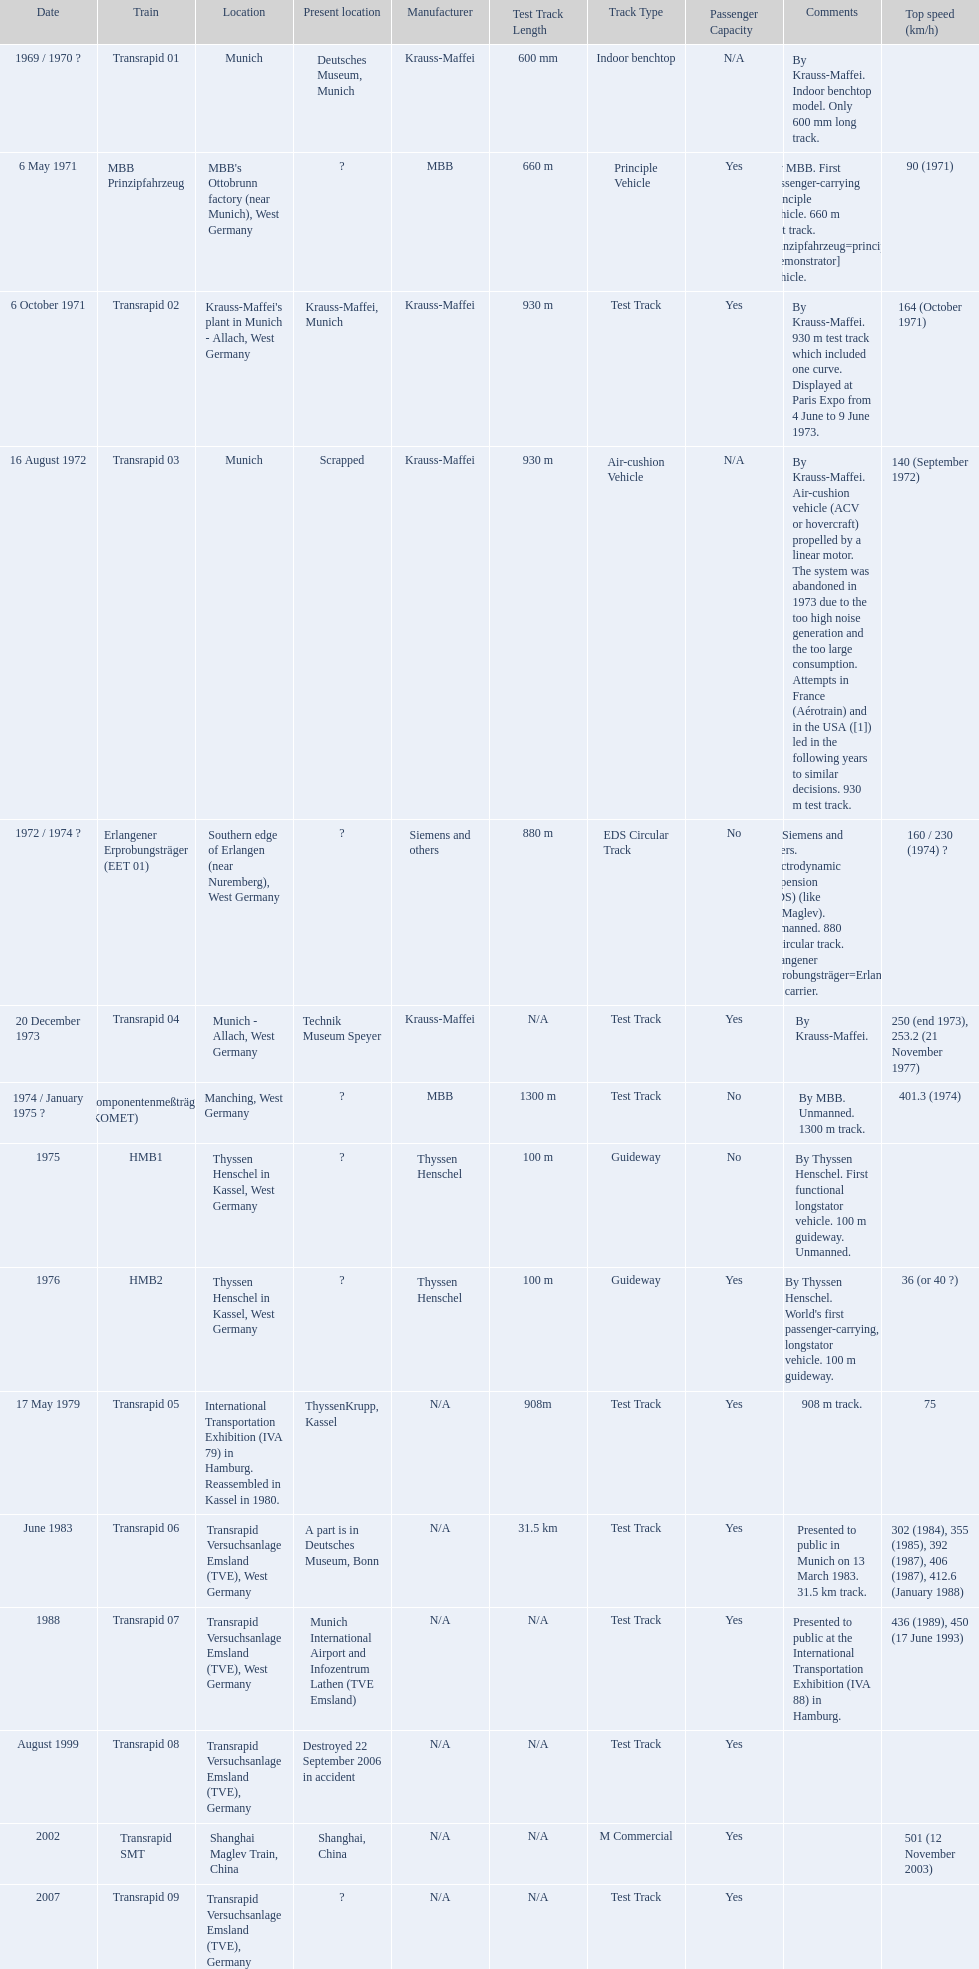How many versions have been scrapped? 1. Could you parse the entire table? {'header': ['Date', 'Train', 'Location', 'Present location', 'Manufacturer', 'Test Track Length', 'Track Type', 'Passenger Capacity', 'Comments', 'Top speed (km/h)'], 'rows': [['1969 / 1970\xa0?', 'Transrapid 01', 'Munich', 'Deutsches Museum, Munich', 'Krauss-Maffei', '600 mm', 'Indoor benchtop', 'N/A', 'By Krauss-Maffei. Indoor benchtop model. Only 600\xa0mm long track.', ''], ['6 May 1971', 'MBB Prinzipfahrzeug', "MBB's Ottobrunn factory (near Munich), West Germany", '?', 'MBB', '660 m', 'Principle Vehicle', 'Yes', 'By MBB. First passenger-carrying principle vehicle. 660 m test track. Prinzipfahrzeug=principle [demonstrator] vehicle.', '90 (1971)'], ['6 October 1971', 'Transrapid 02', "Krauss-Maffei's plant in Munich - Allach, West Germany", 'Krauss-Maffei, Munich', 'Krauss-Maffei', '930 m', 'Test Track', 'Yes', 'By Krauss-Maffei. 930 m test track which included one curve. Displayed at Paris Expo from 4 June to 9 June 1973.', '164 (October 1971)'], ['16 August 1972', 'Transrapid 03', 'Munich', 'Scrapped', 'Krauss-Maffei', '930 m', 'Air-cushion Vehicle', 'N/A', 'By Krauss-Maffei. Air-cushion vehicle (ACV or hovercraft) propelled by a linear motor. The system was abandoned in 1973 due to the too high noise generation and the too large consumption. Attempts in France (Aérotrain) and in the USA ([1]) led in the following years to similar decisions. 930 m test track.', '140 (September 1972)'], ['1972 / 1974\xa0?', 'Erlangener Erprobungsträger (EET 01)', 'Southern edge of Erlangen (near Nuremberg), West Germany', '?', 'Siemens and others', '880 m', 'EDS Circular Track', 'No', 'By Siemens and others. Electrodynamic suspension (EDS) (like JR-Maglev). Unmanned. 880 m circular track. Erlangener Erprobungsträger=Erlangen test carrier.', '160 / 230 (1974)\xa0?'], ['20 December 1973', 'Transrapid 04', 'Munich - Allach, West Germany', 'Technik Museum Speyer', 'Krauss-Maffei', 'N/A', 'Test Track', 'Yes', 'By Krauss-Maffei.', '250 (end 1973), 253.2 (21 November 1977)'], ['1974 / January 1975\xa0?', 'Komponentenmeßträger (KOMET)', 'Manching, West Germany', '?', 'MBB', '1300 m', 'Test Track', 'No', 'By MBB. Unmanned. 1300 m track.', '401.3 (1974)'], ['1975', 'HMB1', 'Thyssen Henschel in Kassel, West Germany', '?', 'Thyssen Henschel', '100 m', 'Guideway', 'No', 'By Thyssen Henschel. First functional longstator vehicle. 100 m guideway. Unmanned.', ''], ['1976', 'HMB2', 'Thyssen Henschel in Kassel, West Germany', '?', 'Thyssen Henschel', '100 m', 'Guideway', 'Yes', "By Thyssen Henschel. World's first passenger-carrying, longstator vehicle. 100 m guideway.", '36 (or 40\xa0?)'], ['17 May 1979', 'Transrapid 05', 'International Transportation Exhibition (IVA 79) in Hamburg. Reassembled in Kassel in 1980.', 'ThyssenKrupp, Kassel', 'N/A', '908m', 'Test Track', 'Yes', '908 m track.', '75'], ['June 1983', 'Transrapid 06', 'Transrapid Versuchsanlage Emsland (TVE), West Germany', 'A part is in Deutsches Museum, Bonn', 'N/A', '31.5 km', 'Test Track', 'Yes', 'Presented to public in Munich on 13 March 1983. 31.5\xa0km track.', '302 (1984), 355 (1985), 392 (1987), 406 (1987), 412.6 (January 1988)'], ['1988', 'Transrapid 07', 'Transrapid Versuchsanlage Emsland (TVE), West Germany', 'Munich International Airport and Infozentrum Lathen (TVE Emsland)', 'N/A', 'N/A', 'Test Track', 'Yes', 'Presented to public at the International Transportation Exhibition (IVA 88) in Hamburg.', '436 (1989), 450 (17 June 1993)'], ['August 1999', 'Transrapid 08', 'Transrapid Versuchsanlage Emsland (TVE), Germany', 'Destroyed 22 September 2006 in accident', 'N/A', 'N/A', 'Test Track', 'Yes', '', ''], ['2002', 'Transrapid SMT', 'Shanghai Maglev Train, China', 'Shanghai, China', 'N/A', 'N/A', 'M Commercial', 'Yes', '', '501 (12 November 2003)'], ['2007', 'Transrapid 09', 'Transrapid Versuchsanlage Emsland (TVE), Germany', '?', 'N/A', 'N/A', 'Test Track', 'Yes', '', '']]} 